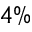<formula> <loc_0><loc_0><loc_500><loc_500>4 \%</formula> 